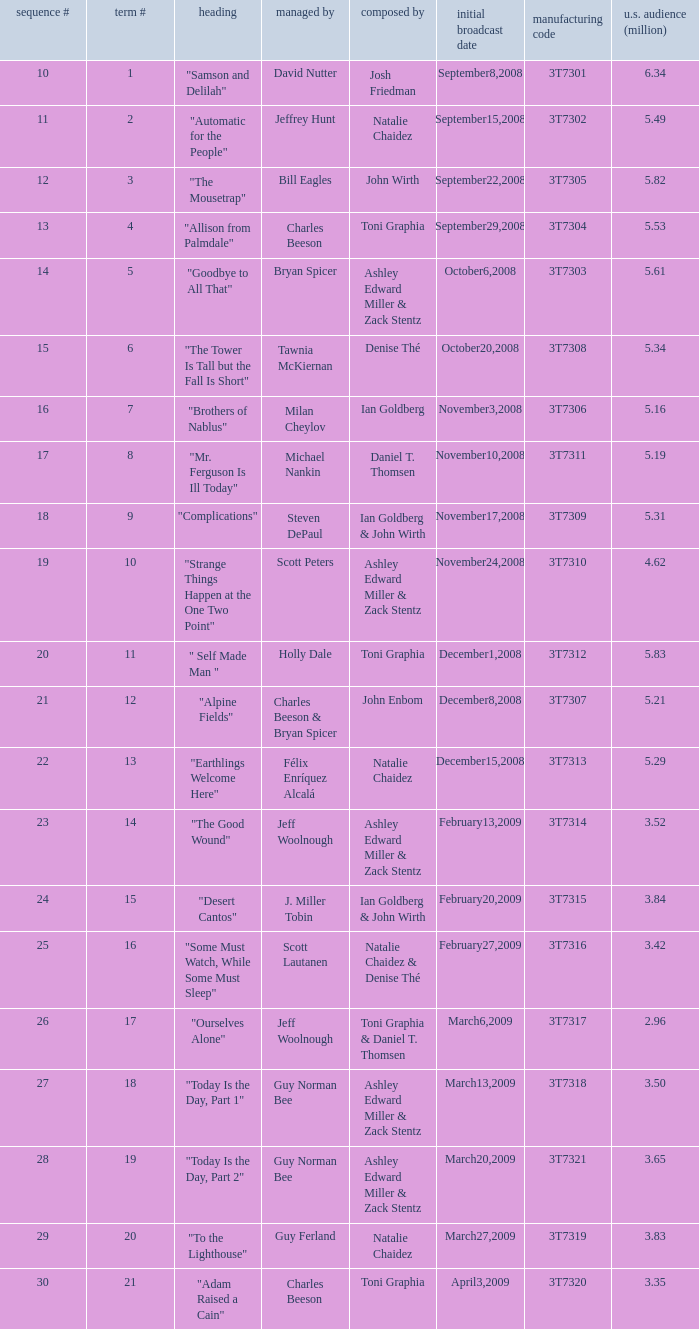Which episode number drew in 3.35 million viewers in the United States? 1.0. 